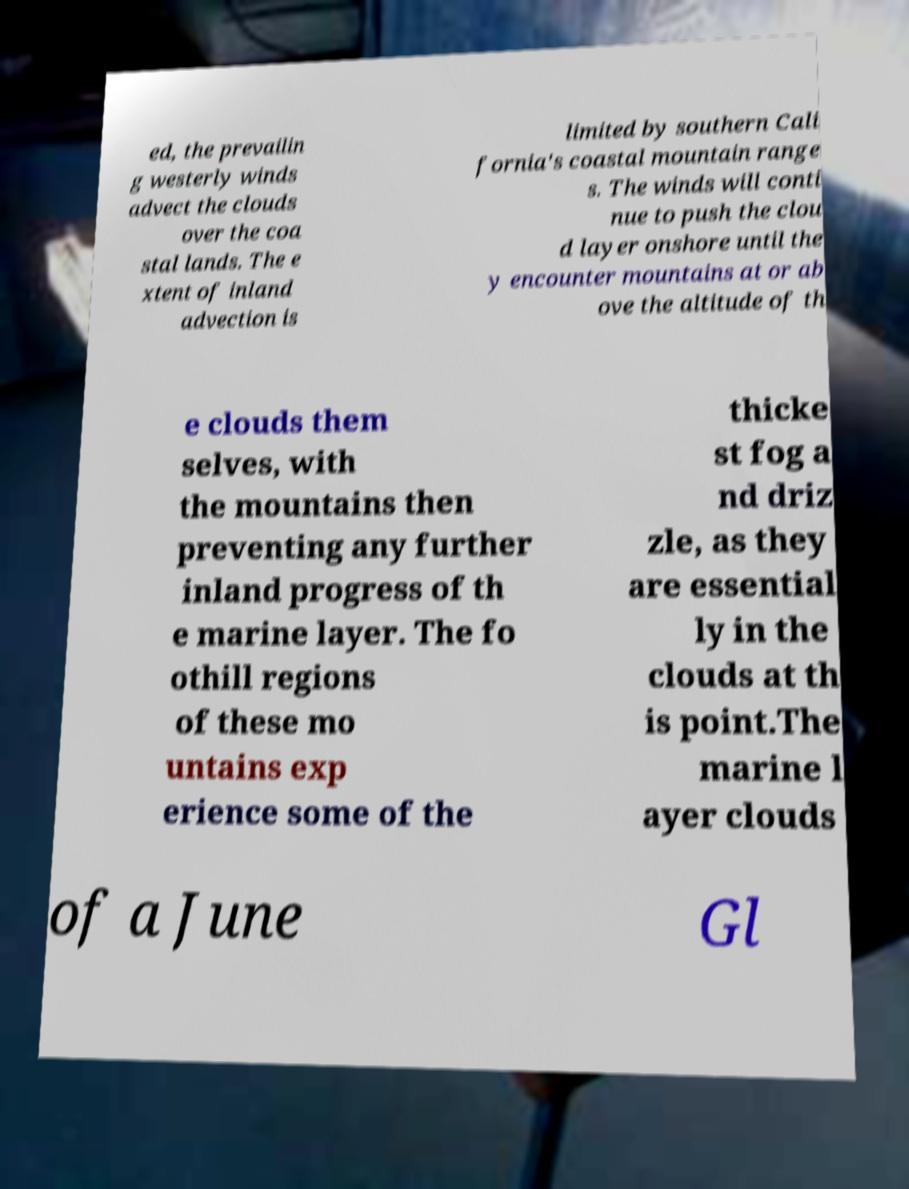Can you read and provide the text displayed in the image?This photo seems to have some interesting text. Can you extract and type it out for me? ed, the prevailin g westerly winds advect the clouds over the coa stal lands. The e xtent of inland advection is limited by southern Cali fornia's coastal mountain range s. The winds will conti nue to push the clou d layer onshore until the y encounter mountains at or ab ove the altitude of th e clouds them selves, with the mountains then preventing any further inland progress of th e marine layer. The fo othill regions of these mo untains exp erience some of the thicke st fog a nd driz zle, as they are essential ly in the clouds at th is point.The marine l ayer clouds of a June Gl 